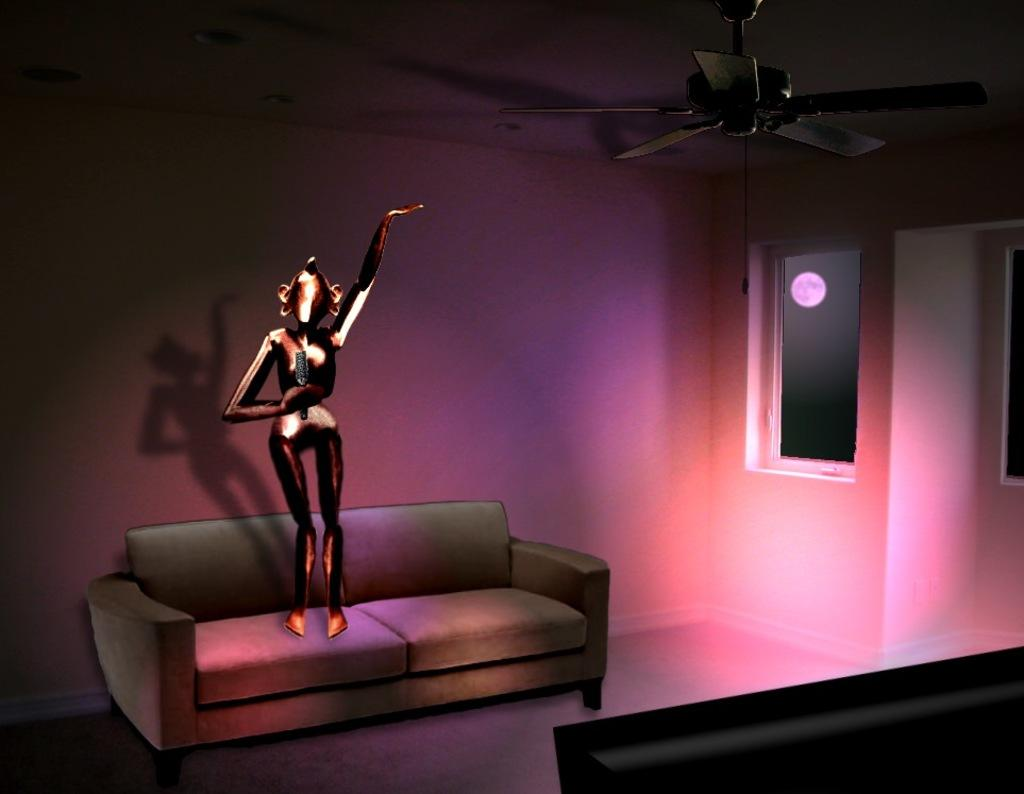What is the doll doing in the image? The doll is standing on a couch in the image. What other objects can be seen in the image? There is a fan and a window in the image. What can be seen through the window? The moon is visible through the window. What type of image is this? The image appears to be animated. What type of guitar is the doll playing in the image? There is no guitar present in the image; the doll is standing on a couch. 